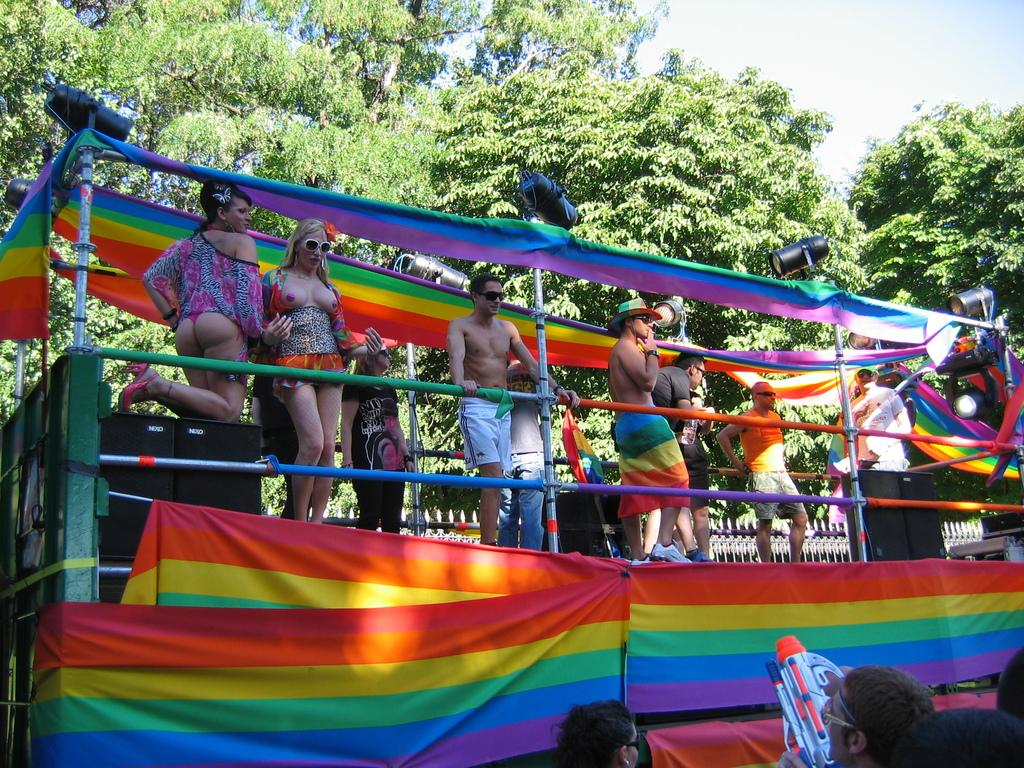What types of people are standing in the image? There are men and women standing in the image. What can be seen in the background of the image? There are trees in the background of the image. Are there any carriages visible in the image? There are no carriages present in the image. What type of pest can be seen crawling on the men and women in the image? There are no pests visible on the men and women in the image. 